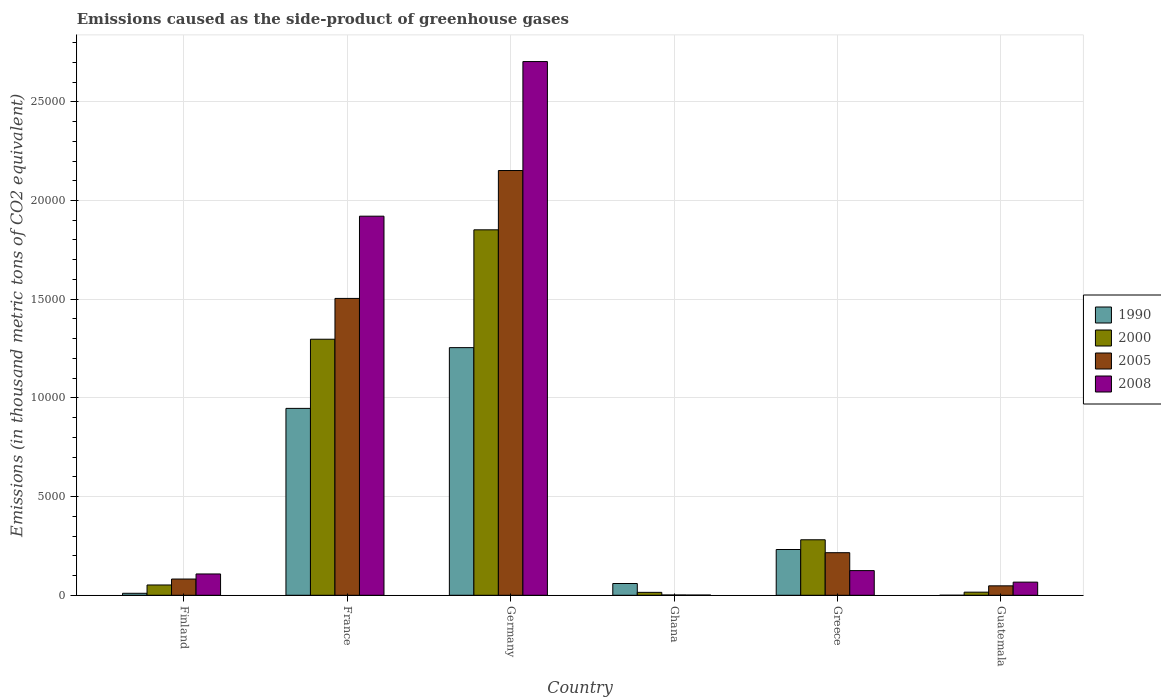Are the number of bars per tick equal to the number of legend labels?
Your answer should be compact. Yes. Are the number of bars on each tick of the X-axis equal?
Ensure brevity in your answer.  Yes. What is the label of the 6th group of bars from the left?
Provide a succinct answer. Guatemala. What is the emissions caused as the side-product of greenhouse gases in 1990 in Greece?
Offer a very short reply. 2318.5. Across all countries, what is the maximum emissions caused as the side-product of greenhouse gases in 1990?
Your answer should be compact. 1.25e+04. In which country was the emissions caused as the side-product of greenhouse gases in 2008 maximum?
Provide a short and direct response. Germany. What is the total emissions caused as the side-product of greenhouse gases in 1990 in the graph?
Make the answer very short. 2.50e+04. What is the difference between the emissions caused as the side-product of greenhouse gases in 2005 in Finland and that in France?
Give a very brief answer. -1.42e+04. What is the difference between the emissions caused as the side-product of greenhouse gases in 2000 in Guatemala and the emissions caused as the side-product of greenhouse gases in 2008 in Ghana?
Give a very brief answer. 146.4. What is the average emissions caused as the side-product of greenhouse gases in 2005 per country?
Your response must be concise. 6671.45. What is the difference between the emissions caused as the side-product of greenhouse gases of/in 2008 and emissions caused as the side-product of greenhouse gases of/in 2005 in Greece?
Provide a short and direct response. -906.8. In how many countries, is the emissions caused as the side-product of greenhouse gases in 2005 greater than 23000 thousand metric tons?
Provide a short and direct response. 0. What is the ratio of the emissions caused as the side-product of greenhouse gases in 2000 in Finland to that in Germany?
Make the answer very short. 0.03. What is the difference between the highest and the second highest emissions caused as the side-product of greenhouse gases in 1990?
Your answer should be compact. 3077.5. What is the difference between the highest and the lowest emissions caused as the side-product of greenhouse gases in 2008?
Provide a short and direct response. 2.70e+04. Is it the case that in every country, the sum of the emissions caused as the side-product of greenhouse gases in 2005 and emissions caused as the side-product of greenhouse gases in 2000 is greater than the emissions caused as the side-product of greenhouse gases in 1990?
Your answer should be very brief. No. Are all the bars in the graph horizontal?
Keep it short and to the point. No. How many countries are there in the graph?
Offer a terse response. 6. Does the graph contain any zero values?
Make the answer very short. No. Where does the legend appear in the graph?
Ensure brevity in your answer.  Center right. How many legend labels are there?
Give a very brief answer. 4. How are the legend labels stacked?
Offer a very short reply. Vertical. What is the title of the graph?
Offer a very short reply. Emissions caused as the side-product of greenhouse gases. Does "1969" appear as one of the legend labels in the graph?
Give a very brief answer. No. What is the label or title of the Y-axis?
Offer a very short reply. Emissions (in thousand metric tons of CO2 equivalent). What is the Emissions (in thousand metric tons of CO2 equivalent) of 1990 in Finland?
Provide a short and direct response. 100.2. What is the Emissions (in thousand metric tons of CO2 equivalent) in 2000 in Finland?
Offer a terse response. 521.8. What is the Emissions (in thousand metric tons of CO2 equivalent) in 2005 in Finland?
Give a very brief answer. 822.5. What is the Emissions (in thousand metric tons of CO2 equivalent) in 2008 in Finland?
Ensure brevity in your answer.  1079.5. What is the Emissions (in thousand metric tons of CO2 equivalent) in 1990 in France?
Offer a very short reply. 9468.2. What is the Emissions (in thousand metric tons of CO2 equivalent) of 2000 in France?
Keep it short and to the point. 1.30e+04. What is the Emissions (in thousand metric tons of CO2 equivalent) of 2005 in France?
Ensure brevity in your answer.  1.50e+04. What is the Emissions (in thousand metric tons of CO2 equivalent) of 2008 in France?
Offer a terse response. 1.92e+04. What is the Emissions (in thousand metric tons of CO2 equivalent) of 1990 in Germany?
Your answer should be compact. 1.25e+04. What is the Emissions (in thousand metric tons of CO2 equivalent) in 2000 in Germany?
Give a very brief answer. 1.85e+04. What is the Emissions (in thousand metric tons of CO2 equivalent) in 2005 in Germany?
Offer a very short reply. 2.15e+04. What is the Emissions (in thousand metric tons of CO2 equivalent) in 2008 in Germany?
Provide a short and direct response. 2.70e+04. What is the Emissions (in thousand metric tons of CO2 equivalent) of 1990 in Ghana?
Offer a terse response. 596.2. What is the Emissions (in thousand metric tons of CO2 equivalent) of 2000 in Ghana?
Offer a terse response. 148. What is the Emissions (in thousand metric tons of CO2 equivalent) in 2005 in Ghana?
Give a very brief answer. 14.7. What is the Emissions (in thousand metric tons of CO2 equivalent) in 1990 in Greece?
Your answer should be very brief. 2318.5. What is the Emissions (in thousand metric tons of CO2 equivalent) in 2000 in Greece?
Your response must be concise. 2811.5. What is the Emissions (in thousand metric tons of CO2 equivalent) in 2005 in Greece?
Offer a terse response. 2157. What is the Emissions (in thousand metric tons of CO2 equivalent) in 2008 in Greece?
Your answer should be compact. 1250.2. What is the Emissions (in thousand metric tons of CO2 equivalent) of 1990 in Guatemala?
Provide a short and direct response. 0.1. What is the Emissions (in thousand metric tons of CO2 equivalent) in 2000 in Guatemala?
Your answer should be compact. 157.6. What is the Emissions (in thousand metric tons of CO2 equivalent) in 2005 in Guatemala?
Your answer should be very brief. 477.8. What is the Emissions (in thousand metric tons of CO2 equivalent) of 2008 in Guatemala?
Your answer should be very brief. 665.8. Across all countries, what is the maximum Emissions (in thousand metric tons of CO2 equivalent) of 1990?
Make the answer very short. 1.25e+04. Across all countries, what is the maximum Emissions (in thousand metric tons of CO2 equivalent) in 2000?
Offer a terse response. 1.85e+04. Across all countries, what is the maximum Emissions (in thousand metric tons of CO2 equivalent) in 2005?
Give a very brief answer. 2.15e+04. Across all countries, what is the maximum Emissions (in thousand metric tons of CO2 equivalent) of 2008?
Your response must be concise. 2.70e+04. Across all countries, what is the minimum Emissions (in thousand metric tons of CO2 equivalent) in 2000?
Make the answer very short. 148. Across all countries, what is the minimum Emissions (in thousand metric tons of CO2 equivalent) in 2008?
Give a very brief answer. 11.2. What is the total Emissions (in thousand metric tons of CO2 equivalent) of 1990 in the graph?
Offer a very short reply. 2.50e+04. What is the total Emissions (in thousand metric tons of CO2 equivalent) in 2000 in the graph?
Provide a succinct answer. 3.51e+04. What is the total Emissions (in thousand metric tons of CO2 equivalent) of 2005 in the graph?
Your answer should be very brief. 4.00e+04. What is the total Emissions (in thousand metric tons of CO2 equivalent) of 2008 in the graph?
Ensure brevity in your answer.  4.92e+04. What is the difference between the Emissions (in thousand metric tons of CO2 equivalent) of 1990 in Finland and that in France?
Provide a succinct answer. -9368. What is the difference between the Emissions (in thousand metric tons of CO2 equivalent) in 2000 in Finland and that in France?
Offer a terse response. -1.24e+04. What is the difference between the Emissions (in thousand metric tons of CO2 equivalent) of 2005 in Finland and that in France?
Offer a very short reply. -1.42e+04. What is the difference between the Emissions (in thousand metric tons of CO2 equivalent) of 2008 in Finland and that in France?
Keep it short and to the point. -1.81e+04. What is the difference between the Emissions (in thousand metric tons of CO2 equivalent) in 1990 in Finland and that in Germany?
Ensure brevity in your answer.  -1.24e+04. What is the difference between the Emissions (in thousand metric tons of CO2 equivalent) in 2000 in Finland and that in Germany?
Ensure brevity in your answer.  -1.80e+04. What is the difference between the Emissions (in thousand metric tons of CO2 equivalent) of 2005 in Finland and that in Germany?
Keep it short and to the point. -2.07e+04. What is the difference between the Emissions (in thousand metric tons of CO2 equivalent) of 2008 in Finland and that in Germany?
Make the answer very short. -2.60e+04. What is the difference between the Emissions (in thousand metric tons of CO2 equivalent) in 1990 in Finland and that in Ghana?
Offer a terse response. -496. What is the difference between the Emissions (in thousand metric tons of CO2 equivalent) of 2000 in Finland and that in Ghana?
Ensure brevity in your answer.  373.8. What is the difference between the Emissions (in thousand metric tons of CO2 equivalent) of 2005 in Finland and that in Ghana?
Keep it short and to the point. 807.8. What is the difference between the Emissions (in thousand metric tons of CO2 equivalent) in 2008 in Finland and that in Ghana?
Provide a succinct answer. 1068.3. What is the difference between the Emissions (in thousand metric tons of CO2 equivalent) of 1990 in Finland and that in Greece?
Offer a terse response. -2218.3. What is the difference between the Emissions (in thousand metric tons of CO2 equivalent) of 2000 in Finland and that in Greece?
Your answer should be very brief. -2289.7. What is the difference between the Emissions (in thousand metric tons of CO2 equivalent) in 2005 in Finland and that in Greece?
Your answer should be compact. -1334.5. What is the difference between the Emissions (in thousand metric tons of CO2 equivalent) in 2008 in Finland and that in Greece?
Offer a terse response. -170.7. What is the difference between the Emissions (in thousand metric tons of CO2 equivalent) of 1990 in Finland and that in Guatemala?
Provide a succinct answer. 100.1. What is the difference between the Emissions (in thousand metric tons of CO2 equivalent) of 2000 in Finland and that in Guatemala?
Offer a very short reply. 364.2. What is the difference between the Emissions (in thousand metric tons of CO2 equivalent) of 2005 in Finland and that in Guatemala?
Provide a short and direct response. 344.7. What is the difference between the Emissions (in thousand metric tons of CO2 equivalent) in 2008 in Finland and that in Guatemala?
Provide a succinct answer. 413.7. What is the difference between the Emissions (in thousand metric tons of CO2 equivalent) in 1990 in France and that in Germany?
Give a very brief answer. -3077.5. What is the difference between the Emissions (in thousand metric tons of CO2 equivalent) of 2000 in France and that in Germany?
Offer a terse response. -5542.7. What is the difference between the Emissions (in thousand metric tons of CO2 equivalent) in 2005 in France and that in Germany?
Your answer should be very brief. -6478.3. What is the difference between the Emissions (in thousand metric tons of CO2 equivalent) in 2008 in France and that in Germany?
Provide a short and direct response. -7832.8. What is the difference between the Emissions (in thousand metric tons of CO2 equivalent) of 1990 in France and that in Ghana?
Give a very brief answer. 8872. What is the difference between the Emissions (in thousand metric tons of CO2 equivalent) in 2000 in France and that in Ghana?
Your response must be concise. 1.28e+04. What is the difference between the Emissions (in thousand metric tons of CO2 equivalent) in 2005 in France and that in Ghana?
Your response must be concise. 1.50e+04. What is the difference between the Emissions (in thousand metric tons of CO2 equivalent) in 2008 in France and that in Ghana?
Offer a terse response. 1.92e+04. What is the difference between the Emissions (in thousand metric tons of CO2 equivalent) in 1990 in France and that in Greece?
Your answer should be compact. 7149.7. What is the difference between the Emissions (in thousand metric tons of CO2 equivalent) of 2000 in France and that in Greece?
Offer a terse response. 1.02e+04. What is the difference between the Emissions (in thousand metric tons of CO2 equivalent) of 2005 in France and that in Greece?
Provide a short and direct response. 1.29e+04. What is the difference between the Emissions (in thousand metric tons of CO2 equivalent) of 2008 in France and that in Greece?
Make the answer very short. 1.80e+04. What is the difference between the Emissions (in thousand metric tons of CO2 equivalent) of 1990 in France and that in Guatemala?
Give a very brief answer. 9468.1. What is the difference between the Emissions (in thousand metric tons of CO2 equivalent) of 2000 in France and that in Guatemala?
Ensure brevity in your answer.  1.28e+04. What is the difference between the Emissions (in thousand metric tons of CO2 equivalent) of 2005 in France and that in Guatemala?
Your answer should be compact. 1.46e+04. What is the difference between the Emissions (in thousand metric tons of CO2 equivalent) in 2008 in France and that in Guatemala?
Offer a terse response. 1.85e+04. What is the difference between the Emissions (in thousand metric tons of CO2 equivalent) of 1990 in Germany and that in Ghana?
Offer a terse response. 1.19e+04. What is the difference between the Emissions (in thousand metric tons of CO2 equivalent) in 2000 in Germany and that in Ghana?
Your answer should be compact. 1.84e+04. What is the difference between the Emissions (in thousand metric tons of CO2 equivalent) in 2005 in Germany and that in Ghana?
Make the answer very short. 2.15e+04. What is the difference between the Emissions (in thousand metric tons of CO2 equivalent) of 2008 in Germany and that in Ghana?
Your response must be concise. 2.70e+04. What is the difference between the Emissions (in thousand metric tons of CO2 equivalent) of 1990 in Germany and that in Greece?
Provide a succinct answer. 1.02e+04. What is the difference between the Emissions (in thousand metric tons of CO2 equivalent) in 2000 in Germany and that in Greece?
Offer a terse response. 1.57e+04. What is the difference between the Emissions (in thousand metric tons of CO2 equivalent) of 2005 in Germany and that in Greece?
Make the answer very short. 1.94e+04. What is the difference between the Emissions (in thousand metric tons of CO2 equivalent) of 2008 in Germany and that in Greece?
Ensure brevity in your answer.  2.58e+04. What is the difference between the Emissions (in thousand metric tons of CO2 equivalent) of 1990 in Germany and that in Guatemala?
Offer a terse response. 1.25e+04. What is the difference between the Emissions (in thousand metric tons of CO2 equivalent) of 2000 in Germany and that in Guatemala?
Your answer should be compact. 1.84e+04. What is the difference between the Emissions (in thousand metric tons of CO2 equivalent) in 2005 in Germany and that in Guatemala?
Offer a very short reply. 2.10e+04. What is the difference between the Emissions (in thousand metric tons of CO2 equivalent) in 2008 in Germany and that in Guatemala?
Your answer should be very brief. 2.64e+04. What is the difference between the Emissions (in thousand metric tons of CO2 equivalent) of 1990 in Ghana and that in Greece?
Your answer should be compact. -1722.3. What is the difference between the Emissions (in thousand metric tons of CO2 equivalent) of 2000 in Ghana and that in Greece?
Keep it short and to the point. -2663.5. What is the difference between the Emissions (in thousand metric tons of CO2 equivalent) in 2005 in Ghana and that in Greece?
Give a very brief answer. -2142.3. What is the difference between the Emissions (in thousand metric tons of CO2 equivalent) of 2008 in Ghana and that in Greece?
Offer a terse response. -1239. What is the difference between the Emissions (in thousand metric tons of CO2 equivalent) of 1990 in Ghana and that in Guatemala?
Your answer should be compact. 596.1. What is the difference between the Emissions (in thousand metric tons of CO2 equivalent) in 2000 in Ghana and that in Guatemala?
Provide a succinct answer. -9.6. What is the difference between the Emissions (in thousand metric tons of CO2 equivalent) of 2005 in Ghana and that in Guatemala?
Give a very brief answer. -463.1. What is the difference between the Emissions (in thousand metric tons of CO2 equivalent) in 2008 in Ghana and that in Guatemala?
Keep it short and to the point. -654.6. What is the difference between the Emissions (in thousand metric tons of CO2 equivalent) in 1990 in Greece and that in Guatemala?
Provide a succinct answer. 2318.4. What is the difference between the Emissions (in thousand metric tons of CO2 equivalent) in 2000 in Greece and that in Guatemala?
Provide a succinct answer. 2653.9. What is the difference between the Emissions (in thousand metric tons of CO2 equivalent) of 2005 in Greece and that in Guatemala?
Your answer should be very brief. 1679.2. What is the difference between the Emissions (in thousand metric tons of CO2 equivalent) of 2008 in Greece and that in Guatemala?
Provide a short and direct response. 584.4. What is the difference between the Emissions (in thousand metric tons of CO2 equivalent) of 1990 in Finland and the Emissions (in thousand metric tons of CO2 equivalent) of 2000 in France?
Your answer should be very brief. -1.29e+04. What is the difference between the Emissions (in thousand metric tons of CO2 equivalent) in 1990 in Finland and the Emissions (in thousand metric tons of CO2 equivalent) in 2005 in France?
Offer a terse response. -1.49e+04. What is the difference between the Emissions (in thousand metric tons of CO2 equivalent) in 1990 in Finland and the Emissions (in thousand metric tons of CO2 equivalent) in 2008 in France?
Provide a succinct answer. -1.91e+04. What is the difference between the Emissions (in thousand metric tons of CO2 equivalent) of 2000 in Finland and the Emissions (in thousand metric tons of CO2 equivalent) of 2005 in France?
Make the answer very short. -1.45e+04. What is the difference between the Emissions (in thousand metric tons of CO2 equivalent) of 2000 in Finland and the Emissions (in thousand metric tons of CO2 equivalent) of 2008 in France?
Offer a very short reply. -1.87e+04. What is the difference between the Emissions (in thousand metric tons of CO2 equivalent) of 2005 in Finland and the Emissions (in thousand metric tons of CO2 equivalent) of 2008 in France?
Your response must be concise. -1.84e+04. What is the difference between the Emissions (in thousand metric tons of CO2 equivalent) of 1990 in Finland and the Emissions (in thousand metric tons of CO2 equivalent) of 2000 in Germany?
Keep it short and to the point. -1.84e+04. What is the difference between the Emissions (in thousand metric tons of CO2 equivalent) of 1990 in Finland and the Emissions (in thousand metric tons of CO2 equivalent) of 2005 in Germany?
Your response must be concise. -2.14e+04. What is the difference between the Emissions (in thousand metric tons of CO2 equivalent) of 1990 in Finland and the Emissions (in thousand metric tons of CO2 equivalent) of 2008 in Germany?
Your answer should be compact. -2.69e+04. What is the difference between the Emissions (in thousand metric tons of CO2 equivalent) of 2000 in Finland and the Emissions (in thousand metric tons of CO2 equivalent) of 2005 in Germany?
Make the answer very short. -2.10e+04. What is the difference between the Emissions (in thousand metric tons of CO2 equivalent) in 2000 in Finland and the Emissions (in thousand metric tons of CO2 equivalent) in 2008 in Germany?
Your response must be concise. -2.65e+04. What is the difference between the Emissions (in thousand metric tons of CO2 equivalent) in 2005 in Finland and the Emissions (in thousand metric tons of CO2 equivalent) in 2008 in Germany?
Your answer should be compact. -2.62e+04. What is the difference between the Emissions (in thousand metric tons of CO2 equivalent) of 1990 in Finland and the Emissions (in thousand metric tons of CO2 equivalent) of 2000 in Ghana?
Ensure brevity in your answer.  -47.8. What is the difference between the Emissions (in thousand metric tons of CO2 equivalent) in 1990 in Finland and the Emissions (in thousand metric tons of CO2 equivalent) in 2005 in Ghana?
Your answer should be compact. 85.5. What is the difference between the Emissions (in thousand metric tons of CO2 equivalent) in 1990 in Finland and the Emissions (in thousand metric tons of CO2 equivalent) in 2008 in Ghana?
Give a very brief answer. 89. What is the difference between the Emissions (in thousand metric tons of CO2 equivalent) in 2000 in Finland and the Emissions (in thousand metric tons of CO2 equivalent) in 2005 in Ghana?
Give a very brief answer. 507.1. What is the difference between the Emissions (in thousand metric tons of CO2 equivalent) of 2000 in Finland and the Emissions (in thousand metric tons of CO2 equivalent) of 2008 in Ghana?
Make the answer very short. 510.6. What is the difference between the Emissions (in thousand metric tons of CO2 equivalent) in 2005 in Finland and the Emissions (in thousand metric tons of CO2 equivalent) in 2008 in Ghana?
Provide a succinct answer. 811.3. What is the difference between the Emissions (in thousand metric tons of CO2 equivalent) in 1990 in Finland and the Emissions (in thousand metric tons of CO2 equivalent) in 2000 in Greece?
Your answer should be very brief. -2711.3. What is the difference between the Emissions (in thousand metric tons of CO2 equivalent) of 1990 in Finland and the Emissions (in thousand metric tons of CO2 equivalent) of 2005 in Greece?
Your answer should be very brief. -2056.8. What is the difference between the Emissions (in thousand metric tons of CO2 equivalent) in 1990 in Finland and the Emissions (in thousand metric tons of CO2 equivalent) in 2008 in Greece?
Offer a very short reply. -1150. What is the difference between the Emissions (in thousand metric tons of CO2 equivalent) of 2000 in Finland and the Emissions (in thousand metric tons of CO2 equivalent) of 2005 in Greece?
Provide a succinct answer. -1635.2. What is the difference between the Emissions (in thousand metric tons of CO2 equivalent) in 2000 in Finland and the Emissions (in thousand metric tons of CO2 equivalent) in 2008 in Greece?
Give a very brief answer. -728.4. What is the difference between the Emissions (in thousand metric tons of CO2 equivalent) in 2005 in Finland and the Emissions (in thousand metric tons of CO2 equivalent) in 2008 in Greece?
Offer a very short reply. -427.7. What is the difference between the Emissions (in thousand metric tons of CO2 equivalent) in 1990 in Finland and the Emissions (in thousand metric tons of CO2 equivalent) in 2000 in Guatemala?
Provide a short and direct response. -57.4. What is the difference between the Emissions (in thousand metric tons of CO2 equivalent) in 1990 in Finland and the Emissions (in thousand metric tons of CO2 equivalent) in 2005 in Guatemala?
Keep it short and to the point. -377.6. What is the difference between the Emissions (in thousand metric tons of CO2 equivalent) of 1990 in Finland and the Emissions (in thousand metric tons of CO2 equivalent) of 2008 in Guatemala?
Provide a short and direct response. -565.6. What is the difference between the Emissions (in thousand metric tons of CO2 equivalent) in 2000 in Finland and the Emissions (in thousand metric tons of CO2 equivalent) in 2005 in Guatemala?
Make the answer very short. 44. What is the difference between the Emissions (in thousand metric tons of CO2 equivalent) of 2000 in Finland and the Emissions (in thousand metric tons of CO2 equivalent) of 2008 in Guatemala?
Offer a terse response. -144. What is the difference between the Emissions (in thousand metric tons of CO2 equivalent) in 2005 in Finland and the Emissions (in thousand metric tons of CO2 equivalent) in 2008 in Guatemala?
Make the answer very short. 156.7. What is the difference between the Emissions (in thousand metric tons of CO2 equivalent) of 1990 in France and the Emissions (in thousand metric tons of CO2 equivalent) of 2000 in Germany?
Provide a short and direct response. -9045.7. What is the difference between the Emissions (in thousand metric tons of CO2 equivalent) in 1990 in France and the Emissions (in thousand metric tons of CO2 equivalent) in 2005 in Germany?
Provide a succinct answer. -1.20e+04. What is the difference between the Emissions (in thousand metric tons of CO2 equivalent) in 1990 in France and the Emissions (in thousand metric tons of CO2 equivalent) in 2008 in Germany?
Provide a short and direct response. -1.76e+04. What is the difference between the Emissions (in thousand metric tons of CO2 equivalent) in 2000 in France and the Emissions (in thousand metric tons of CO2 equivalent) in 2005 in Germany?
Give a very brief answer. -8546.3. What is the difference between the Emissions (in thousand metric tons of CO2 equivalent) in 2000 in France and the Emissions (in thousand metric tons of CO2 equivalent) in 2008 in Germany?
Offer a terse response. -1.41e+04. What is the difference between the Emissions (in thousand metric tons of CO2 equivalent) of 2005 in France and the Emissions (in thousand metric tons of CO2 equivalent) of 2008 in Germany?
Make the answer very short. -1.20e+04. What is the difference between the Emissions (in thousand metric tons of CO2 equivalent) in 1990 in France and the Emissions (in thousand metric tons of CO2 equivalent) in 2000 in Ghana?
Give a very brief answer. 9320.2. What is the difference between the Emissions (in thousand metric tons of CO2 equivalent) in 1990 in France and the Emissions (in thousand metric tons of CO2 equivalent) in 2005 in Ghana?
Your response must be concise. 9453.5. What is the difference between the Emissions (in thousand metric tons of CO2 equivalent) in 1990 in France and the Emissions (in thousand metric tons of CO2 equivalent) in 2008 in Ghana?
Your answer should be compact. 9457. What is the difference between the Emissions (in thousand metric tons of CO2 equivalent) of 2000 in France and the Emissions (in thousand metric tons of CO2 equivalent) of 2005 in Ghana?
Provide a succinct answer. 1.30e+04. What is the difference between the Emissions (in thousand metric tons of CO2 equivalent) in 2000 in France and the Emissions (in thousand metric tons of CO2 equivalent) in 2008 in Ghana?
Keep it short and to the point. 1.30e+04. What is the difference between the Emissions (in thousand metric tons of CO2 equivalent) of 2005 in France and the Emissions (in thousand metric tons of CO2 equivalent) of 2008 in Ghana?
Your answer should be compact. 1.50e+04. What is the difference between the Emissions (in thousand metric tons of CO2 equivalent) of 1990 in France and the Emissions (in thousand metric tons of CO2 equivalent) of 2000 in Greece?
Your answer should be compact. 6656.7. What is the difference between the Emissions (in thousand metric tons of CO2 equivalent) in 1990 in France and the Emissions (in thousand metric tons of CO2 equivalent) in 2005 in Greece?
Make the answer very short. 7311.2. What is the difference between the Emissions (in thousand metric tons of CO2 equivalent) in 1990 in France and the Emissions (in thousand metric tons of CO2 equivalent) in 2008 in Greece?
Make the answer very short. 8218. What is the difference between the Emissions (in thousand metric tons of CO2 equivalent) in 2000 in France and the Emissions (in thousand metric tons of CO2 equivalent) in 2005 in Greece?
Keep it short and to the point. 1.08e+04. What is the difference between the Emissions (in thousand metric tons of CO2 equivalent) in 2000 in France and the Emissions (in thousand metric tons of CO2 equivalent) in 2008 in Greece?
Provide a succinct answer. 1.17e+04. What is the difference between the Emissions (in thousand metric tons of CO2 equivalent) of 2005 in France and the Emissions (in thousand metric tons of CO2 equivalent) of 2008 in Greece?
Offer a terse response. 1.38e+04. What is the difference between the Emissions (in thousand metric tons of CO2 equivalent) in 1990 in France and the Emissions (in thousand metric tons of CO2 equivalent) in 2000 in Guatemala?
Provide a short and direct response. 9310.6. What is the difference between the Emissions (in thousand metric tons of CO2 equivalent) of 1990 in France and the Emissions (in thousand metric tons of CO2 equivalent) of 2005 in Guatemala?
Your answer should be compact. 8990.4. What is the difference between the Emissions (in thousand metric tons of CO2 equivalent) of 1990 in France and the Emissions (in thousand metric tons of CO2 equivalent) of 2008 in Guatemala?
Keep it short and to the point. 8802.4. What is the difference between the Emissions (in thousand metric tons of CO2 equivalent) in 2000 in France and the Emissions (in thousand metric tons of CO2 equivalent) in 2005 in Guatemala?
Your response must be concise. 1.25e+04. What is the difference between the Emissions (in thousand metric tons of CO2 equivalent) in 2000 in France and the Emissions (in thousand metric tons of CO2 equivalent) in 2008 in Guatemala?
Your response must be concise. 1.23e+04. What is the difference between the Emissions (in thousand metric tons of CO2 equivalent) in 2005 in France and the Emissions (in thousand metric tons of CO2 equivalent) in 2008 in Guatemala?
Offer a terse response. 1.44e+04. What is the difference between the Emissions (in thousand metric tons of CO2 equivalent) of 1990 in Germany and the Emissions (in thousand metric tons of CO2 equivalent) of 2000 in Ghana?
Offer a terse response. 1.24e+04. What is the difference between the Emissions (in thousand metric tons of CO2 equivalent) in 1990 in Germany and the Emissions (in thousand metric tons of CO2 equivalent) in 2005 in Ghana?
Your response must be concise. 1.25e+04. What is the difference between the Emissions (in thousand metric tons of CO2 equivalent) in 1990 in Germany and the Emissions (in thousand metric tons of CO2 equivalent) in 2008 in Ghana?
Your response must be concise. 1.25e+04. What is the difference between the Emissions (in thousand metric tons of CO2 equivalent) in 2000 in Germany and the Emissions (in thousand metric tons of CO2 equivalent) in 2005 in Ghana?
Provide a succinct answer. 1.85e+04. What is the difference between the Emissions (in thousand metric tons of CO2 equivalent) of 2000 in Germany and the Emissions (in thousand metric tons of CO2 equivalent) of 2008 in Ghana?
Make the answer very short. 1.85e+04. What is the difference between the Emissions (in thousand metric tons of CO2 equivalent) of 2005 in Germany and the Emissions (in thousand metric tons of CO2 equivalent) of 2008 in Ghana?
Your answer should be compact. 2.15e+04. What is the difference between the Emissions (in thousand metric tons of CO2 equivalent) in 1990 in Germany and the Emissions (in thousand metric tons of CO2 equivalent) in 2000 in Greece?
Keep it short and to the point. 9734.2. What is the difference between the Emissions (in thousand metric tons of CO2 equivalent) of 1990 in Germany and the Emissions (in thousand metric tons of CO2 equivalent) of 2005 in Greece?
Your answer should be very brief. 1.04e+04. What is the difference between the Emissions (in thousand metric tons of CO2 equivalent) of 1990 in Germany and the Emissions (in thousand metric tons of CO2 equivalent) of 2008 in Greece?
Keep it short and to the point. 1.13e+04. What is the difference between the Emissions (in thousand metric tons of CO2 equivalent) of 2000 in Germany and the Emissions (in thousand metric tons of CO2 equivalent) of 2005 in Greece?
Give a very brief answer. 1.64e+04. What is the difference between the Emissions (in thousand metric tons of CO2 equivalent) of 2000 in Germany and the Emissions (in thousand metric tons of CO2 equivalent) of 2008 in Greece?
Your response must be concise. 1.73e+04. What is the difference between the Emissions (in thousand metric tons of CO2 equivalent) in 2005 in Germany and the Emissions (in thousand metric tons of CO2 equivalent) in 2008 in Greece?
Your answer should be very brief. 2.03e+04. What is the difference between the Emissions (in thousand metric tons of CO2 equivalent) of 1990 in Germany and the Emissions (in thousand metric tons of CO2 equivalent) of 2000 in Guatemala?
Provide a short and direct response. 1.24e+04. What is the difference between the Emissions (in thousand metric tons of CO2 equivalent) of 1990 in Germany and the Emissions (in thousand metric tons of CO2 equivalent) of 2005 in Guatemala?
Offer a terse response. 1.21e+04. What is the difference between the Emissions (in thousand metric tons of CO2 equivalent) in 1990 in Germany and the Emissions (in thousand metric tons of CO2 equivalent) in 2008 in Guatemala?
Your answer should be very brief. 1.19e+04. What is the difference between the Emissions (in thousand metric tons of CO2 equivalent) of 2000 in Germany and the Emissions (in thousand metric tons of CO2 equivalent) of 2005 in Guatemala?
Make the answer very short. 1.80e+04. What is the difference between the Emissions (in thousand metric tons of CO2 equivalent) in 2000 in Germany and the Emissions (in thousand metric tons of CO2 equivalent) in 2008 in Guatemala?
Make the answer very short. 1.78e+04. What is the difference between the Emissions (in thousand metric tons of CO2 equivalent) of 2005 in Germany and the Emissions (in thousand metric tons of CO2 equivalent) of 2008 in Guatemala?
Keep it short and to the point. 2.09e+04. What is the difference between the Emissions (in thousand metric tons of CO2 equivalent) in 1990 in Ghana and the Emissions (in thousand metric tons of CO2 equivalent) in 2000 in Greece?
Keep it short and to the point. -2215.3. What is the difference between the Emissions (in thousand metric tons of CO2 equivalent) of 1990 in Ghana and the Emissions (in thousand metric tons of CO2 equivalent) of 2005 in Greece?
Your answer should be compact. -1560.8. What is the difference between the Emissions (in thousand metric tons of CO2 equivalent) of 1990 in Ghana and the Emissions (in thousand metric tons of CO2 equivalent) of 2008 in Greece?
Your response must be concise. -654. What is the difference between the Emissions (in thousand metric tons of CO2 equivalent) of 2000 in Ghana and the Emissions (in thousand metric tons of CO2 equivalent) of 2005 in Greece?
Your response must be concise. -2009. What is the difference between the Emissions (in thousand metric tons of CO2 equivalent) of 2000 in Ghana and the Emissions (in thousand metric tons of CO2 equivalent) of 2008 in Greece?
Provide a succinct answer. -1102.2. What is the difference between the Emissions (in thousand metric tons of CO2 equivalent) of 2005 in Ghana and the Emissions (in thousand metric tons of CO2 equivalent) of 2008 in Greece?
Give a very brief answer. -1235.5. What is the difference between the Emissions (in thousand metric tons of CO2 equivalent) in 1990 in Ghana and the Emissions (in thousand metric tons of CO2 equivalent) in 2000 in Guatemala?
Provide a short and direct response. 438.6. What is the difference between the Emissions (in thousand metric tons of CO2 equivalent) in 1990 in Ghana and the Emissions (in thousand metric tons of CO2 equivalent) in 2005 in Guatemala?
Provide a succinct answer. 118.4. What is the difference between the Emissions (in thousand metric tons of CO2 equivalent) in 1990 in Ghana and the Emissions (in thousand metric tons of CO2 equivalent) in 2008 in Guatemala?
Your response must be concise. -69.6. What is the difference between the Emissions (in thousand metric tons of CO2 equivalent) in 2000 in Ghana and the Emissions (in thousand metric tons of CO2 equivalent) in 2005 in Guatemala?
Your response must be concise. -329.8. What is the difference between the Emissions (in thousand metric tons of CO2 equivalent) in 2000 in Ghana and the Emissions (in thousand metric tons of CO2 equivalent) in 2008 in Guatemala?
Keep it short and to the point. -517.8. What is the difference between the Emissions (in thousand metric tons of CO2 equivalent) in 2005 in Ghana and the Emissions (in thousand metric tons of CO2 equivalent) in 2008 in Guatemala?
Provide a succinct answer. -651.1. What is the difference between the Emissions (in thousand metric tons of CO2 equivalent) of 1990 in Greece and the Emissions (in thousand metric tons of CO2 equivalent) of 2000 in Guatemala?
Offer a terse response. 2160.9. What is the difference between the Emissions (in thousand metric tons of CO2 equivalent) in 1990 in Greece and the Emissions (in thousand metric tons of CO2 equivalent) in 2005 in Guatemala?
Keep it short and to the point. 1840.7. What is the difference between the Emissions (in thousand metric tons of CO2 equivalent) of 1990 in Greece and the Emissions (in thousand metric tons of CO2 equivalent) of 2008 in Guatemala?
Give a very brief answer. 1652.7. What is the difference between the Emissions (in thousand metric tons of CO2 equivalent) of 2000 in Greece and the Emissions (in thousand metric tons of CO2 equivalent) of 2005 in Guatemala?
Offer a very short reply. 2333.7. What is the difference between the Emissions (in thousand metric tons of CO2 equivalent) in 2000 in Greece and the Emissions (in thousand metric tons of CO2 equivalent) in 2008 in Guatemala?
Offer a very short reply. 2145.7. What is the difference between the Emissions (in thousand metric tons of CO2 equivalent) of 2005 in Greece and the Emissions (in thousand metric tons of CO2 equivalent) of 2008 in Guatemala?
Your answer should be very brief. 1491.2. What is the average Emissions (in thousand metric tons of CO2 equivalent) of 1990 per country?
Keep it short and to the point. 4171.48. What is the average Emissions (in thousand metric tons of CO2 equivalent) in 2000 per country?
Offer a very short reply. 5854. What is the average Emissions (in thousand metric tons of CO2 equivalent) in 2005 per country?
Provide a short and direct response. 6671.45. What is the average Emissions (in thousand metric tons of CO2 equivalent) of 2008 per country?
Make the answer very short. 8208.25. What is the difference between the Emissions (in thousand metric tons of CO2 equivalent) in 1990 and Emissions (in thousand metric tons of CO2 equivalent) in 2000 in Finland?
Your response must be concise. -421.6. What is the difference between the Emissions (in thousand metric tons of CO2 equivalent) of 1990 and Emissions (in thousand metric tons of CO2 equivalent) of 2005 in Finland?
Give a very brief answer. -722.3. What is the difference between the Emissions (in thousand metric tons of CO2 equivalent) in 1990 and Emissions (in thousand metric tons of CO2 equivalent) in 2008 in Finland?
Offer a very short reply. -979.3. What is the difference between the Emissions (in thousand metric tons of CO2 equivalent) in 2000 and Emissions (in thousand metric tons of CO2 equivalent) in 2005 in Finland?
Ensure brevity in your answer.  -300.7. What is the difference between the Emissions (in thousand metric tons of CO2 equivalent) of 2000 and Emissions (in thousand metric tons of CO2 equivalent) of 2008 in Finland?
Keep it short and to the point. -557.7. What is the difference between the Emissions (in thousand metric tons of CO2 equivalent) in 2005 and Emissions (in thousand metric tons of CO2 equivalent) in 2008 in Finland?
Your answer should be compact. -257. What is the difference between the Emissions (in thousand metric tons of CO2 equivalent) in 1990 and Emissions (in thousand metric tons of CO2 equivalent) in 2000 in France?
Provide a succinct answer. -3503. What is the difference between the Emissions (in thousand metric tons of CO2 equivalent) of 1990 and Emissions (in thousand metric tons of CO2 equivalent) of 2005 in France?
Ensure brevity in your answer.  -5571. What is the difference between the Emissions (in thousand metric tons of CO2 equivalent) of 1990 and Emissions (in thousand metric tons of CO2 equivalent) of 2008 in France?
Make the answer very short. -9736.8. What is the difference between the Emissions (in thousand metric tons of CO2 equivalent) in 2000 and Emissions (in thousand metric tons of CO2 equivalent) in 2005 in France?
Your answer should be very brief. -2068. What is the difference between the Emissions (in thousand metric tons of CO2 equivalent) in 2000 and Emissions (in thousand metric tons of CO2 equivalent) in 2008 in France?
Give a very brief answer. -6233.8. What is the difference between the Emissions (in thousand metric tons of CO2 equivalent) of 2005 and Emissions (in thousand metric tons of CO2 equivalent) of 2008 in France?
Your answer should be compact. -4165.8. What is the difference between the Emissions (in thousand metric tons of CO2 equivalent) of 1990 and Emissions (in thousand metric tons of CO2 equivalent) of 2000 in Germany?
Your response must be concise. -5968.2. What is the difference between the Emissions (in thousand metric tons of CO2 equivalent) of 1990 and Emissions (in thousand metric tons of CO2 equivalent) of 2005 in Germany?
Your answer should be very brief. -8971.8. What is the difference between the Emissions (in thousand metric tons of CO2 equivalent) in 1990 and Emissions (in thousand metric tons of CO2 equivalent) in 2008 in Germany?
Your response must be concise. -1.45e+04. What is the difference between the Emissions (in thousand metric tons of CO2 equivalent) in 2000 and Emissions (in thousand metric tons of CO2 equivalent) in 2005 in Germany?
Your answer should be compact. -3003.6. What is the difference between the Emissions (in thousand metric tons of CO2 equivalent) of 2000 and Emissions (in thousand metric tons of CO2 equivalent) of 2008 in Germany?
Make the answer very short. -8523.9. What is the difference between the Emissions (in thousand metric tons of CO2 equivalent) in 2005 and Emissions (in thousand metric tons of CO2 equivalent) in 2008 in Germany?
Provide a succinct answer. -5520.3. What is the difference between the Emissions (in thousand metric tons of CO2 equivalent) of 1990 and Emissions (in thousand metric tons of CO2 equivalent) of 2000 in Ghana?
Your answer should be compact. 448.2. What is the difference between the Emissions (in thousand metric tons of CO2 equivalent) in 1990 and Emissions (in thousand metric tons of CO2 equivalent) in 2005 in Ghana?
Offer a very short reply. 581.5. What is the difference between the Emissions (in thousand metric tons of CO2 equivalent) of 1990 and Emissions (in thousand metric tons of CO2 equivalent) of 2008 in Ghana?
Keep it short and to the point. 585. What is the difference between the Emissions (in thousand metric tons of CO2 equivalent) of 2000 and Emissions (in thousand metric tons of CO2 equivalent) of 2005 in Ghana?
Your answer should be compact. 133.3. What is the difference between the Emissions (in thousand metric tons of CO2 equivalent) in 2000 and Emissions (in thousand metric tons of CO2 equivalent) in 2008 in Ghana?
Ensure brevity in your answer.  136.8. What is the difference between the Emissions (in thousand metric tons of CO2 equivalent) in 2005 and Emissions (in thousand metric tons of CO2 equivalent) in 2008 in Ghana?
Provide a succinct answer. 3.5. What is the difference between the Emissions (in thousand metric tons of CO2 equivalent) of 1990 and Emissions (in thousand metric tons of CO2 equivalent) of 2000 in Greece?
Your answer should be compact. -493. What is the difference between the Emissions (in thousand metric tons of CO2 equivalent) in 1990 and Emissions (in thousand metric tons of CO2 equivalent) in 2005 in Greece?
Offer a terse response. 161.5. What is the difference between the Emissions (in thousand metric tons of CO2 equivalent) in 1990 and Emissions (in thousand metric tons of CO2 equivalent) in 2008 in Greece?
Offer a very short reply. 1068.3. What is the difference between the Emissions (in thousand metric tons of CO2 equivalent) of 2000 and Emissions (in thousand metric tons of CO2 equivalent) of 2005 in Greece?
Make the answer very short. 654.5. What is the difference between the Emissions (in thousand metric tons of CO2 equivalent) of 2000 and Emissions (in thousand metric tons of CO2 equivalent) of 2008 in Greece?
Your answer should be compact. 1561.3. What is the difference between the Emissions (in thousand metric tons of CO2 equivalent) in 2005 and Emissions (in thousand metric tons of CO2 equivalent) in 2008 in Greece?
Provide a short and direct response. 906.8. What is the difference between the Emissions (in thousand metric tons of CO2 equivalent) in 1990 and Emissions (in thousand metric tons of CO2 equivalent) in 2000 in Guatemala?
Offer a very short reply. -157.5. What is the difference between the Emissions (in thousand metric tons of CO2 equivalent) in 1990 and Emissions (in thousand metric tons of CO2 equivalent) in 2005 in Guatemala?
Provide a short and direct response. -477.7. What is the difference between the Emissions (in thousand metric tons of CO2 equivalent) in 1990 and Emissions (in thousand metric tons of CO2 equivalent) in 2008 in Guatemala?
Provide a short and direct response. -665.7. What is the difference between the Emissions (in thousand metric tons of CO2 equivalent) in 2000 and Emissions (in thousand metric tons of CO2 equivalent) in 2005 in Guatemala?
Your answer should be compact. -320.2. What is the difference between the Emissions (in thousand metric tons of CO2 equivalent) of 2000 and Emissions (in thousand metric tons of CO2 equivalent) of 2008 in Guatemala?
Give a very brief answer. -508.2. What is the difference between the Emissions (in thousand metric tons of CO2 equivalent) in 2005 and Emissions (in thousand metric tons of CO2 equivalent) in 2008 in Guatemala?
Provide a succinct answer. -188. What is the ratio of the Emissions (in thousand metric tons of CO2 equivalent) of 1990 in Finland to that in France?
Provide a succinct answer. 0.01. What is the ratio of the Emissions (in thousand metric tons of CO2 equivalent) of 2000 in Finland to that in France?
Keep it short and to the point. 0.04. What is the ratio of the Emissions (in thousand metric tons of CO2 equivalent) in 2005 in Finland to that in France?
Your answer should be very brief. 0.05. What is the ratio of the Emissions (in thousand metric tons of CO2 equivalent) of 2008 in Finland to that in France?
Give a very brief answer. 0.06. What is the ratio of the Emissions (in thousand metric tons of CO2 equivalent) of 1990 in Finland to that in Germany?
Offer a very short reply. 0.01. What is the ratio of the Emissions (in thousand metric tons of CO2 equivalent) in 2000 in Finland to that in Germany?
Provide a succinct answer. 0.03. What is the ratio of the Emissions (in thousand metric tons of CO2 equivalent) in 2005 in Finland to that in Germany?
Make the answer very short. 0.04. What is the ratio of the Emissions (in thousand metric tons of CO2 equivalent) of 2008 in Finland to that in Germany?
Your answer should be compact. 0.04. What is the ratio of the Emissions (in thousand metric tons of CO2 equivalent) of 1990 in Finland to that in Ghana?
Ensure brevity in your answer.  0.17. What is the ratio of the Emissions (in thousand metric tons of CO2 equivalent) in 2000 in Finland to that in Ghana?
Your answer should be compact. 3.53. What is the ratio of the Emissions (in thousand metric tons of CO2 equivalent) in 2005 in Finland to that in Ghana?
Your response must be concise. 55.95. What is the ratio of the Emissions (in thousand metric tons of CO2 equivalent) of 2008 in Finland to that in Ghana?
Keep it short and to the point. 96.38. What is the ratio of the Emissions (in thousand metric tons of CO2 equivalent) of 1990 in Finland to that in Greece?
Make the answer very short. 0.04. What is the ratio of the Emissions (in thousand metric tons of CO2 equivalent) of 2000 in Finland to that in Greece?
Make the answer very short. 0.19. What is the ratio of the Emissions (in thousand metric tons of CO2 equivalent) of 2005 in Finland to that in Greece?
Your response must be concise. 0.38. What is the ratio of the Emissions (in thousand metric tons of CO2 equivalent) of 2008 in Finland to that in Greece?
Your answer should be compact. 0.86. What is the ratio of the Emissions (in thousand metric tons of CO2 equivalent) of 1990 in Finland to that in Guatemala?
Keep it short and to the point. 1002. What is the ratio of the Emissions (in thousand metric tons of CO2 equivalent) of 2000 in Finland to that in Guatemala?
Offer a terse response. 3.31. What is the ratio of the Emissions (in thousand metric tons of CO2 equivalent) of 2005 in Finland to that in Guatemala?
Your response must be concise. 1.72. What is the ratio of the Emissions (in thousand metric tons of CO2 equivalent) in 2008 in Finland to that in Guatemala?
Give a very brief answer. 1.62. What is the ratio of the Emissions (in thousand metric tons of CO2 equivalent) of 1990 in France to that in Germany?
Your response must be concise. 0.75. What is the ratio of the Emissions (in thousand metric tons of CO2 equivalent) of 2000 in France to that in Germany?
Your response must be concise. 0.7. What is the ratio of the Emissions (in thousand metric tons of CO2 equivalent) of 2005 in France to that in Germany?
Your response must be concise. 0.7. What is the ratio of the Emissions (in thousand metric tons of CO2 equivalent) in 2008 in France to that in Germany?
Give a very brief answer. 0.71. What is the ratio of the Emissions (in thousand metric tons of CO2 equivalent) in 1990 in France to that in Ghana?
Your answer should be compact. 15.88. What is the ratio of the Emissions (in thousand metric tons of CO2 equivalent) in 2000 in France to that in Ghana?
Your answer should be very brief. 87.64. What is the ratio of the Emissions (in thousand metric tons of CO2 equivalent) of 2005 in France to that in Ghana?
Provide a short and direct response. 1023.07. What is the ratio of the Emissions (in thousand metric tons of CO2 equivalent) of 2008 in France to that in Ghana?
Keep it short and to the point. 1714.73. What is the ratio of the Emissions (in thousand metric tons of CO2 equivalent) in 1990 in France to that in Greece?
Your response must be concise. 4.08. What is the ratio of the Emissions (in thousand metric tons of CO2 equivalent) of 2000 in France to that in Greece?
Your response must be concise. 4.61. What is the ratio of the Emissions (in thousand metric tons of CO2 equivalent) in 2005 in France to that in Greece?
Your answer should be very brief. 6.97. What is the ratio of the Emissions (in thousand metric tons of CO2 equivalent) of 2008 in France to that in Greece?
Provide a succinct answer. 15.36. What is the ratio of the Emissions (in thousand metric tons of CO2 equivalent) in 1990 in France to that in Guatemala?
Your response must be concise. 9.47e+04. What is the ratio of the Emissions (in thousand metric tons of CO2 equivalent) of 2000 in France to that in Guatemala?
Your answer should be very brief. 82.3. What is the ratio of the Emissions (in thousand metric tons of CO2 equivalent) of 2005 in France to that in Guatemala?
Your response must be concise. 31.48. What is the ratio of the Emissions (in thousand metric tons of CO2 equivalent) of 2008 in France to that in Guatemala?
Offer a very short reply. 28.84. What is the ratio of the Emissions (in thousand metric tons of CO2 equivalent) of 1990 in Germany to that in Ghana?
Provide a short and direct response. 21.04. What is the ratio of the Emissions (in thousand metric tons of CO2 equivalent) in 2000 in Germany to that in Ghana?
Keep it short and to the point. 125.09. What is the ratio of the Emissions (in thousand metric tons of CO2 equivalent) of 2005 in Germany to that in Ghana?
Offer a very short reply. 1463.78. What is the ratio of the Emissions (in thousand metric tons of CO2 equivalent) in 2008 in Germany to that in Ghana?
Your answer should be very brief. 2414.09. What is the ratio of the Emissions (in thousand metric tons of CO2 equivalent) in 1990 in Germany to that in Greece?
Your response must be concise. 5.41. What is the ratio of the Emissions (in thousand metric tons of CO2 equivalent) in 2000 in Germany to that in Greece?
Provide a short and direct response. 6.59. What is the ratio of the Emissions (in thousand metric tons of CO2 equivalent) in 2005 in Germany to that in Greece?
Keep it short and to the point. 9.98. What is the ratio of the Emissions (in thousand metric tons of CO2 equivalent) of 2008 in Germany to that in Greece?
Keep it short and to the point. 21.63. What is the ratio of the Emissions (in thousand metric tons of CO2 equivalent) in 1990 in Germany to that in Guatemala?
Your answer should be compact. 1.25e+05. What is the ratio of the Emissions (in thousand metric tons of CO2 equivalent) in 2000 in Germany to that in Guatemala?
Your response must be concise. 117.47. What is the ratio of the Emissions (in thousand metric tons of CO2 equivalent) of 2005 in Germany to that in Guatemala?
Your answer should be very brief. 45.03. What is the ratio of the Emissions (in thousand metric tons of CO2 equivalent) in 2008 in Germany to that in Guatemala?
Your answer should be very brief. 40.61. What is the ratio of the Emissions (in thousand metric tons of CO2 equivalent) of 1990 in Ghana to that in Greece?
Ensure brevity in your answer.  0.26. What is the ratio of the Emissions (in thousand metric tons of CO2 equivalent) of 2000 in Ghana to that in Greece?
Ensure brevity in your answer.  0.05. What is the ratio of the Emissions (in thousand metric tons of CO2 equivalent) of 2005 in Ghana to that in Greece?
Ensure brevity in your answer.  0.01. What is the ratio of the Emissions (in thousand metric tons of CO2 equivalent) in 2008 in Ghana to that in Greece?
Provide a short and direct response. 0.01. What is the ratio of the Emissions (in thousand metric tons of CO2 equivalent) of 1990 in Ghana to that in Guatemala?
Your answer should be compact. 5962. What is the ratio of the Emissions (in thousand metric tons of CO2 equivalent) in 2000 in Ghana to that in Guatemala?
Make the answer very short. 0.94. What is the ratio of the Emissions (in thousand metric tons of CO2 equivalent) in 2005 in Ghana to that in Guatemala?
Provide a succinct answer. 0.03. What is the ratio of the Emissions (in thousand metric tons of CO2 equivalent) of 2008 in Ghana to that in Guatemala?
Give a very brief answer. 0.02. What is the ratio of the Emissions (in thousand metric tons of CO2 equivalent) in 1990 in Greece to that in Guatemala?
Your response must be concise. 2.32e+04. What is the ratio of the Emissions (in thousand metric tons of CO2 equivalent) of 2000 in Greece to that in Guatemala?
Provide a short and direct response. 17.84. What is the ratio of the Emissions (in thousand metric tons of CO2 equivalent) in 2005 in Greece to that in Guatemala?
Your answer should be compact. 4.51. What is the ratio of the Emissions (in thousand metric tons of CO2 equivalent) in 2008 in Greece to that in Guatemala?
Make the answer very short. 1.88. What is the difference between the highest and the second highest Emissions (in thousand metric tons of CO2 equivalent) in 1990?
Offer a very short reply. 3077.5. What is the difference between the highest and the second highest Emissions (in thousand metric tons of CO2 equivalent) in 2000?
Offer a very short reply. 5542.7. What is the difference between the highest and the second highest Emissions (in thousand metric tons of CO2 equivalent) in 2005?
Offer a very short reply. 6478.3. What is the difference between the highest and the second highest Emissions (in thousand metric tons of CO2 equivalent) of 2008?
Your answer should be compact. 7832.8. What is the difference between the highest and the lowest Emissions (in thousand metric tons of CO2 equivalent) of 1990?
Give a very brief answer. 1.25e+04. What is the difference between the highest and the lowest Emissions (in thousand metric tons of CO2 equivalent) in 2000?
Offer a terse response. 1.84e+04. What is the difference between the highest and the lowest Emissions (in thousand metric tons of CO2 equivalent) of 2005?
Give a very brief answer. 2.15e+04. What is the difference between the highest and the lowest Emissions (in thousand metric tons of CO2 equivalent) of 2008?
Give a very brief answer. 2.70e+04. 